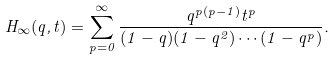<formula> <loc_0><loc_0><loc_500><loc_500>H _ { \infty } ( q , t ) = \sum _ { p = 0 } ^ { \infty } \frac { q ^ { p ( p - 1 ) } t ^ { p } } { ( 1 - q ) ( 1 - q ^ { 2 } ) \cdots ( 1 - q ^ { p } ) } .</formula> 